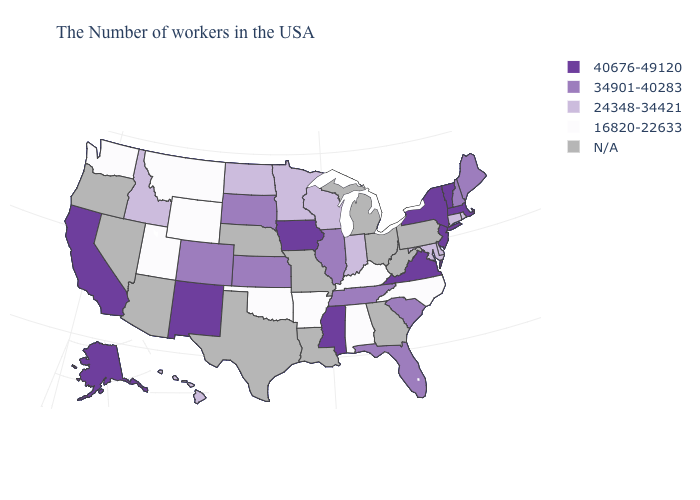What is the value of Colorado?
Quick response, please. 34901-40283. What is the value of Virginia?
Write a very short answer. 40676-49120. Name the states that have a value in the range N/A?
Concise answer only. Pennsylvania, West Virginia, Ohio, Georgia, Michigan, Louisiana, Missouri, Nebraska, Texas, Arizona, Nevada, Oregon. What is the highest value in states that border South Carolina?
Write a very short answer. 16820-22633. What is the value of Missouri?
Answer briefly. N/A. What is the value of Connecticut?
Write a very short answer. 24348-34421. Does the map have missing data?
Short answer required. Yes. What is the value of Connecticut?
Keep it brief. 24348-34421. What is the highest value in the USA?
Short answer required. 40676-49120. Does the map have missing data?
Write a very short answer. Yes. What is the value of Georgia?
Quick response, please. N/A. Name the states that have a value in the range 34901-40283?
Give a very brief answer. Maine, New Hampshire, South Carolina, Florida, Tennessee, Illinois, Kansas, South Dakota, Colorado. What is the value of Pennsylvania?
Answer briefly. N/A. Is the legend a continuous bar?
Give a very brief answer. No. 